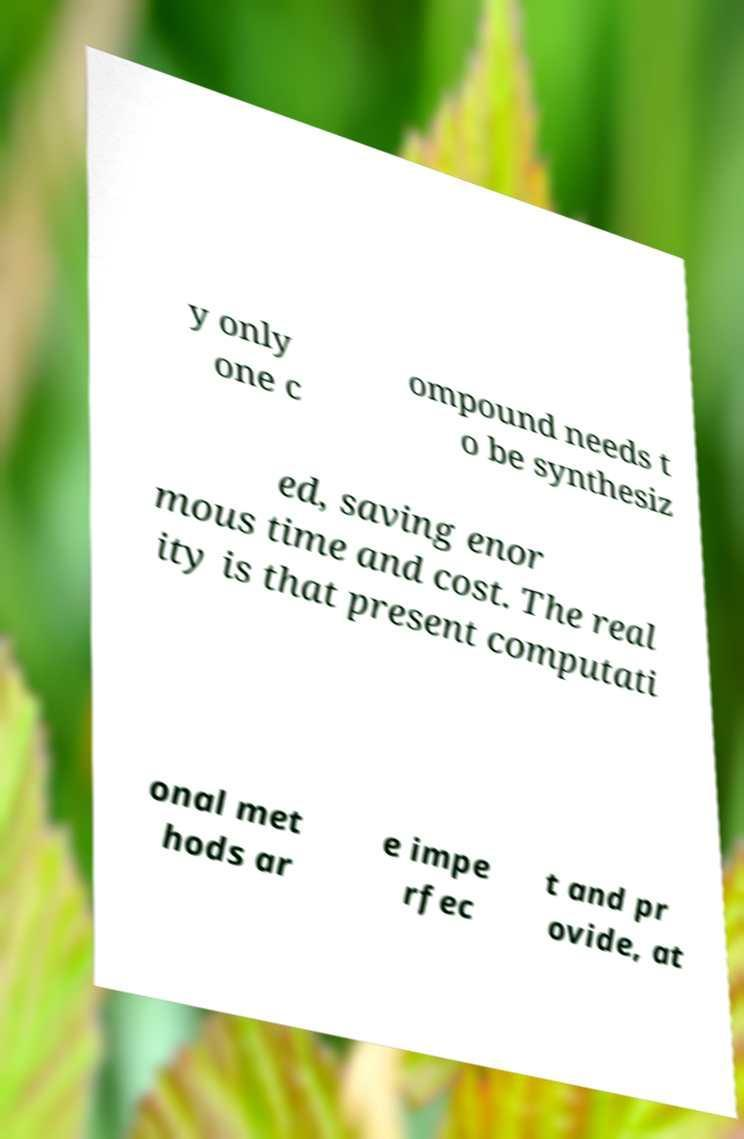Please read and relay the text visible in this image. What does it say? y only one c ompound needs t o be synthesiz ed, saving enor mous time and cost. The real ity is that present computati onal met hods ar e impe rfec t and pr ovide, at 